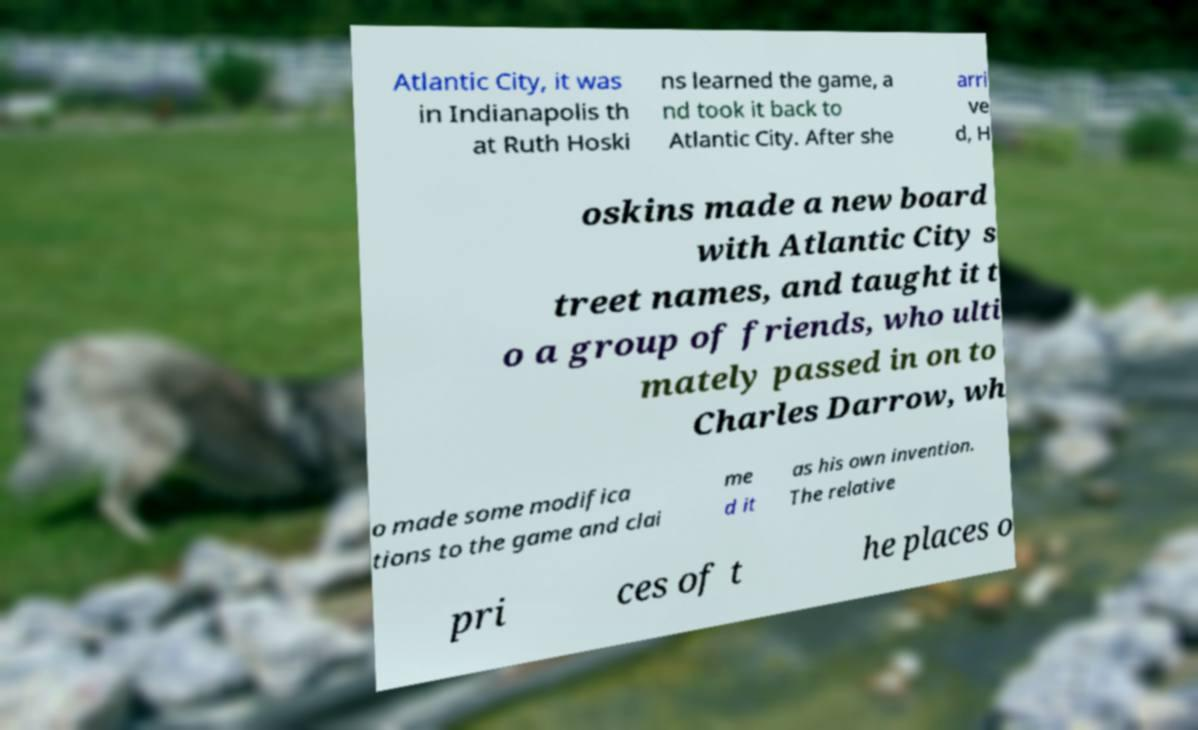There's text embedded in this image that I need extracted. Can you transcribe it verbatim? Atlantic City, it was in Indianapolis th at Ruth Hoski ns learned the game, a nd took it back to Atlantic City. After she arri ve d, H oskins made a new board with Atlantic City s treet names, and taught it t o a group of friends, who ulti mately passed in on to Charles Darrow, wh o made some modifica tions to the game and clai me d it as his own invention. The relative pri ces of t he places o 